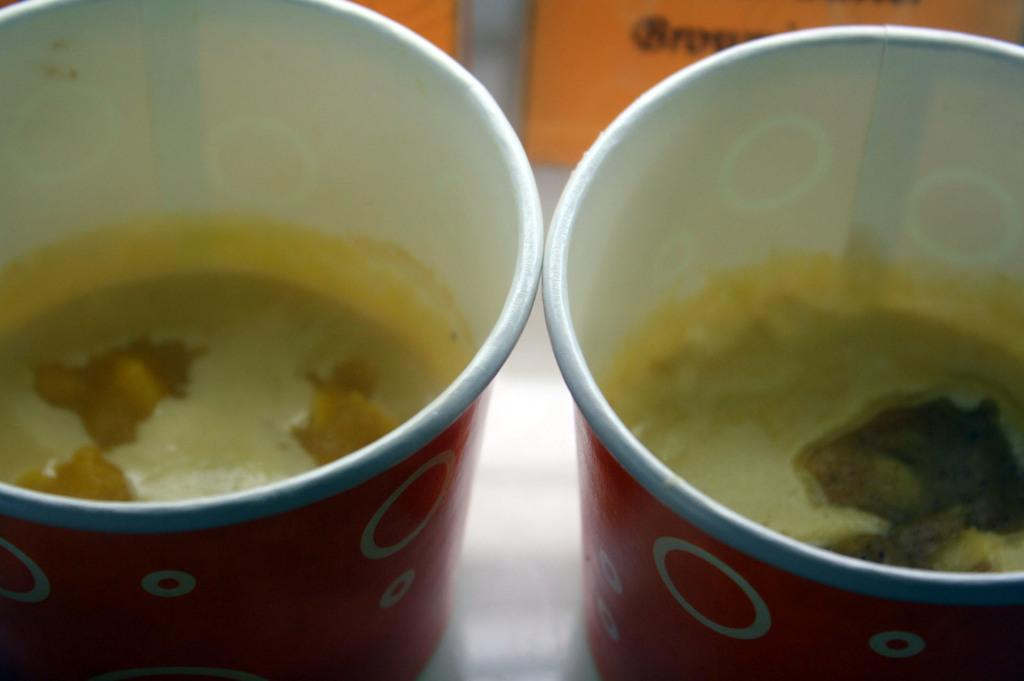What color are the cups in the image? The cups are red in the image. What is inside the cups? The cups contain juice. Can you describe any other objects in the image with a color? There is an orange color thing present in the image. How does the deer use the cups in the image? There is no deer present in the image, so it cannot use the cups. 